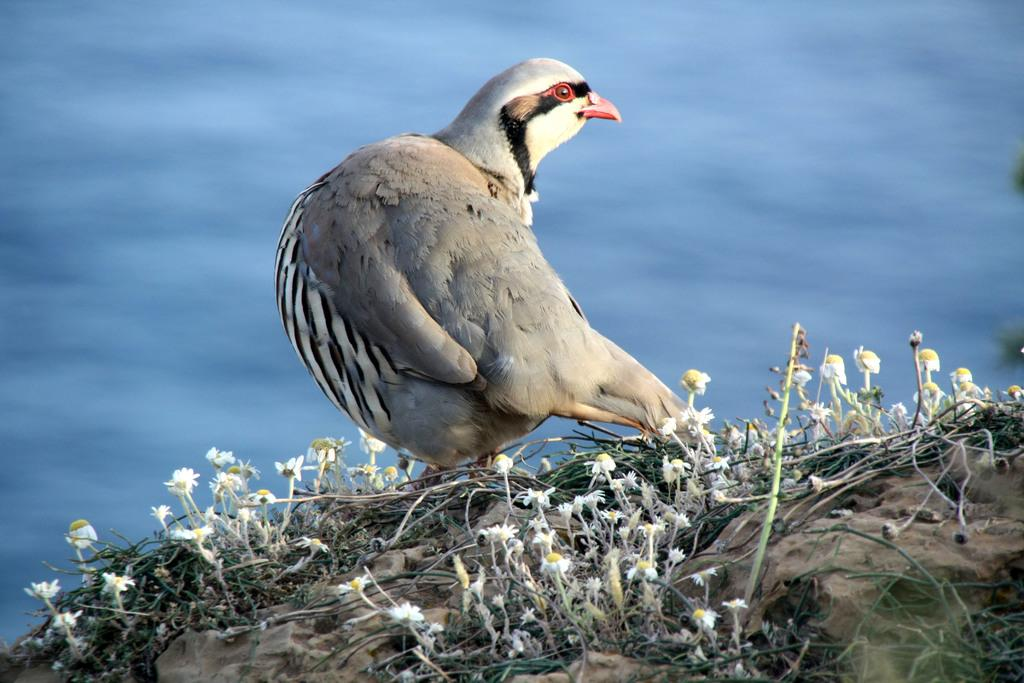What is the main subject in the center of the image? There is a bird in the center of the image. What can be seen at the bottom side of the image? There are small flowers at the bottom side of the image. What is visible in the background of the image? There is water visible in the background of the image. What type of behavior does the father exhibit in the image? There is no father present in the image, so it is not possible to determine any behavior. 